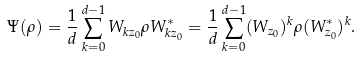Convert formula to latex. <formula><loc_0><loc_0><loc_500><loc_500>\Psi ( \rho ) = \frac { 1 } { d } \sum _ { k = 0 } ^ { d - 1 } W _ { k z _ { 0 } } \rho W _ { k z _ { 0 } } ^ { \ast } = \frac { 1 } { d } \sum _ { k = 0 } ^ { d - 1 } ( W _ { z _ { 0 } } ) ^ { k } \rho ( W _ { z _ { 0 } } ^ { \ast } ) ^ { k } .</formula> 